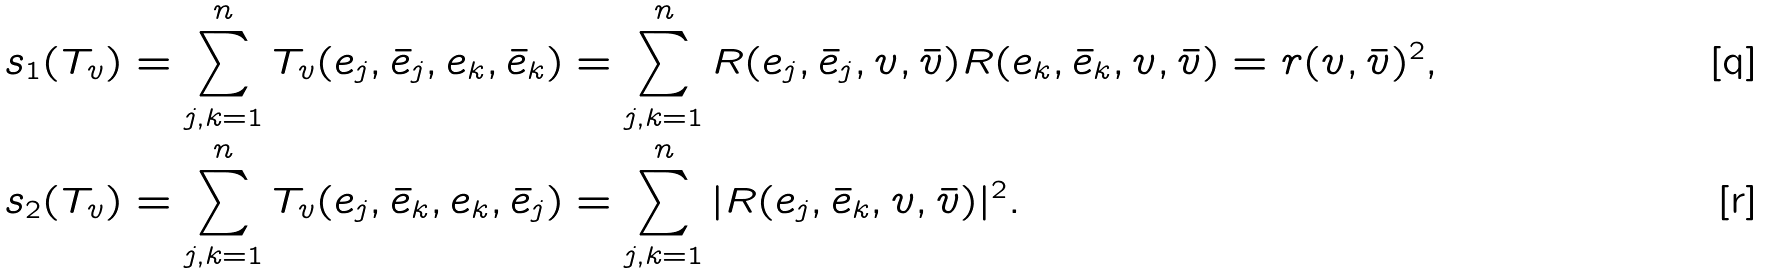Convert formula to latex. <formula><loc_0><loc_0><loc_500><loc_500>s _ { 1 } ( T _ { v } ) & = \sum _ { j , k = 1 } ^ { n } T _ { v } ( e _ { j } , \bar { e } _ { j } , e _ { k } , \bar { e } _ { k } ) = \sum _ { j , k = 1 } ^ { n } R ( e _ { j } , \bar { e } _ { j } , v , \bar { v } ) R ( e _ { k } , \bar { e } _ { k } , v , \bar { v } ) = r ( v , \bar { v } ) ^ { 2 } , \\ s _ { 2 } ( T _ { v } ) & = \sum _ { j , k = 1 } ^ { n } T _ { v } ( e _ { j } , \bar { e } _ { k } , e _ { k } , \bar { e } _ { j } ) = \sum _ { j , k = 1 } ^ { n } | R ( e _ { j } , \bar { e } _ { k } , v , \bar { v } ) | ^ { 2 } .</formula> 